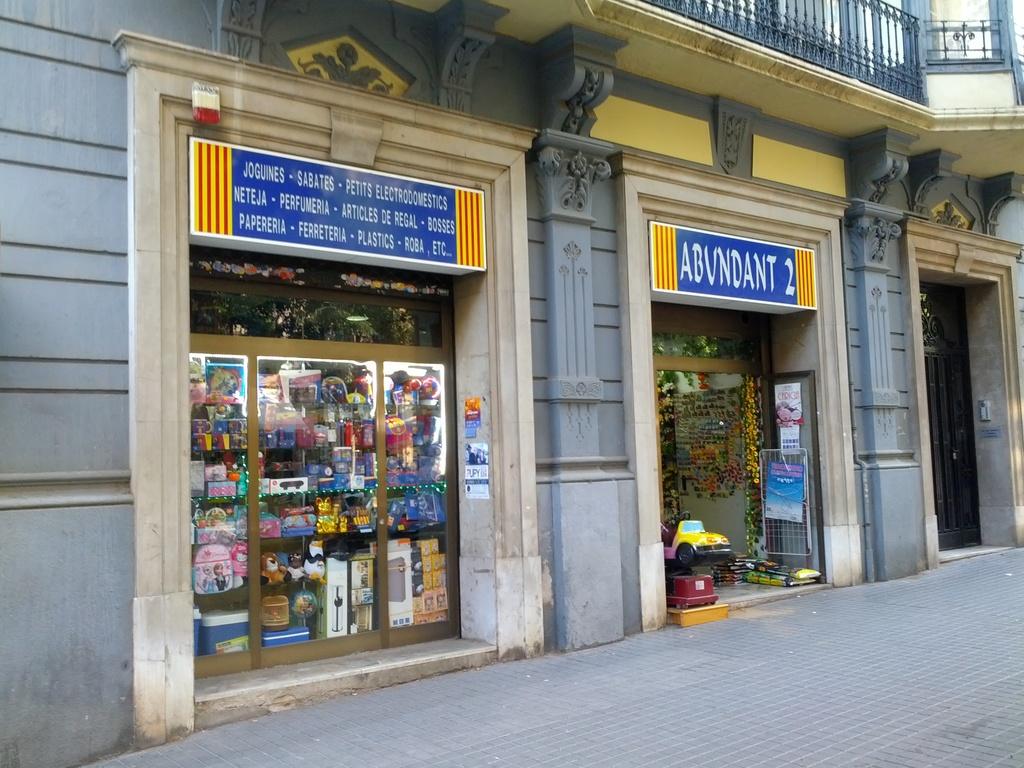What is the store name on the right in blue signage?
Offer a terse response. Abundant 2. What is the first word on the sign on the left?
Your response must be concise. Joguines. 